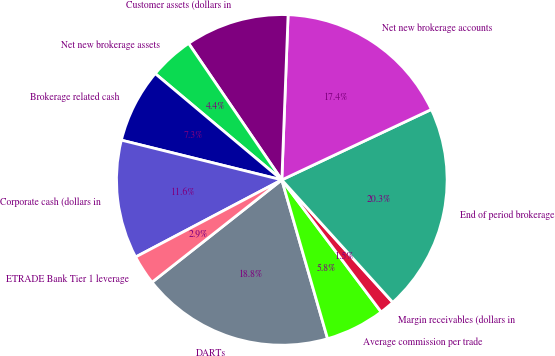Convert chart to OTSL. <chart><loc_0><loc_0><loc_500><loc_500><pie_chart><fcel>DARTs<fcel>Average commission per trade<fcel>Margin receivables (dollars in<fcel>End of period brokerage<fcel>Net new brokerage accounts<fcel>Customer assets (dollars in<fcel>Net new brokerage assets<fcel>Brokerage related cash<fcel>Corporate cash (dollars in<fcel>ETRADE Bank Tier 1 leverage<nl><fcel>18.84%<fcel>5.8%<fcel>1.45%<fcel>20.29%<fcel>17.39%<fcel>10.14%<fcel>4.35%<fcel>7.25%<fcel>11.59%<fcel>2.9%<nl></chart> 